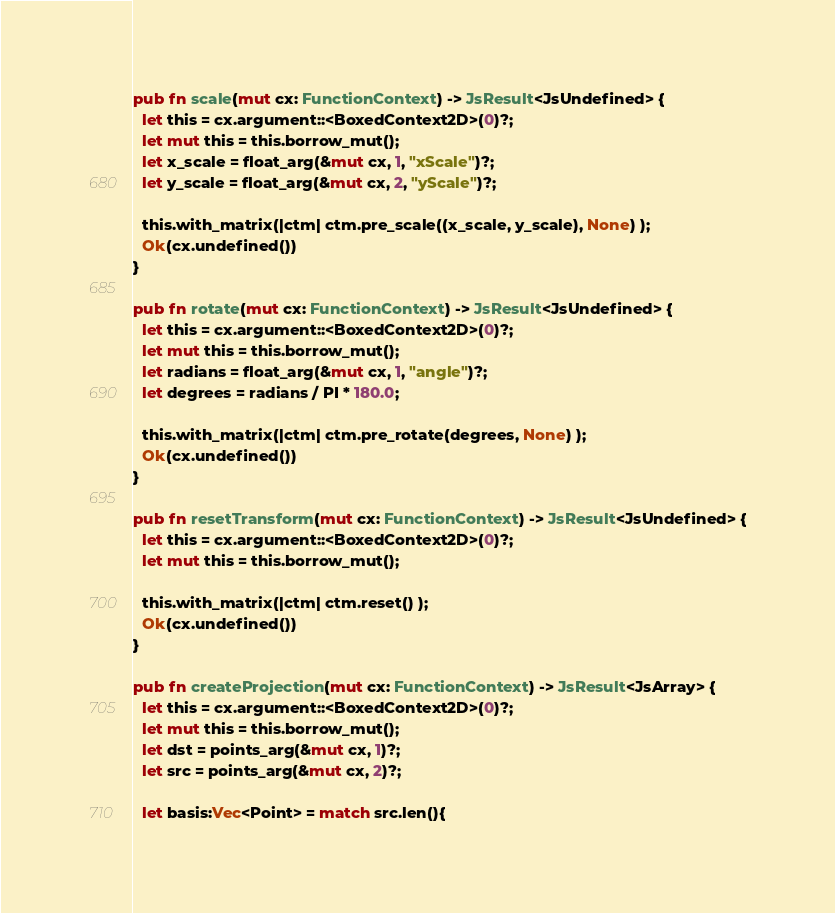Convert code to text. <code><loc_0><loc_0><loc_500><loc_500><_Rust_>pub fn scale(mut cx: FunctionContext) -> JsResult<JsUndefined> {
  let this = cx.argument::<BoxedContext2D>(0)?;
  let mut this = this.borrow_mut();
  let x_scale = float_arg(&mut cx, 1, "xScale")?;
  let y_scale = float_arg(&mut cx, 2, "yScale")?;

  this.with_matrix(|ctm| ctm.pre_scale((x_scale, y_scale), None) );
  Ok(cx.undefined())
}

pub fn rotate(mut cx: FunctionContext) -> JsResult<JsUndefined> {
  let this = cx.argument::<BoxedContext2D>(0)?;
  let mut this = this.borrow_mut();
  let radians = float_arg(&mut cx, 1, "angle")?;
  let degrees = radians / PI * 180.0;

  this.with_matrix(|ctm| ctm.pre_rotate(degrees, None) );
  Ok(cx.undefined())
}

pub fn resetTransform(mut cx: FunctionContext) -> JsResult<JsUndefined> {
  let this = cx.argument::<BoxedContext2D>(0)?;
  let mut this = this.borrow_mut();

  this.with_matrix(|ctm| ctm.reset() );
  Ok(cx.undefined())
}

pub fn createProjection(mut cx: FunctionContext) -> JsResult<JsArray> {
  let this = cx.argument::<BoxedContext2D>(0)?;
  let mut this = this.borrow_mut();
  let dst = points_arg(&mut cx, 1)?;
  let src = points_arg(&mut cx, 2)?;

  let basis:Vec<Point> = match src.len(){</code> 